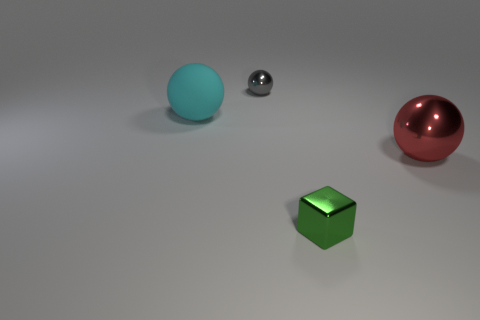Are there any other things that have the same color as the large metallic object?
Ensure brevity in your answer.  No. What is the shape of the small thing that is in front of the sphere that is in front of the big object that is to the left of the gray shiny ball?
Make the answer very short. Cube. Do the metallic ball right of the green cube and the cyan rubber object behind the big red metallic sphere have the same size?
Make the answer very short. Yes. How many large red balls are the same material as the green thing?
Provide a succinct answer. 1. What number of red spheres are on the left side of the metal sphere in front of the tiny thing behind the tiny green shiny thing?
Your response must be concise. 0. Is the large cyan matte thing the same shape as the red object?
Your response must be concise. Yes. Is there a small metallic object of the same shape as the cyan matte thing?
Provide a short and direct response. Yes. There is a gray metal thing that is the same size as the green metal thing; what shape is it?
Give a very brief answer. Sphere. What material is the tiny object behind the big object in front of the big ball that is behind the big red metal thing made of?
Your answer should be very brief. Metal. Do the cyan ball and the green metallic object have the same size?
Ensure brevity in your answer.  No. 